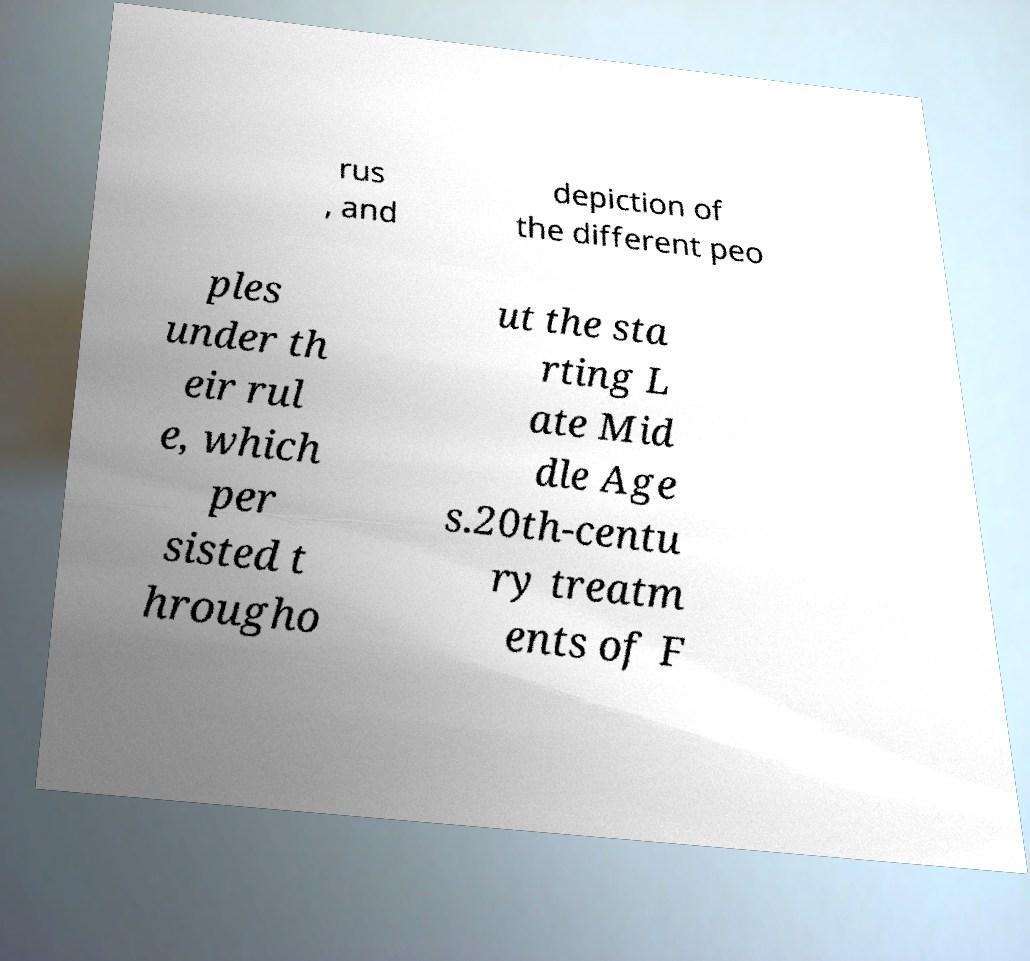Please identify and transcribe the text found in this image. rus , and depiction of the different peo ples under th eir rul e, which per sisted t hrougho ut the sta rting L ate Mid dle Age s.20th-centu ry treatm ents of F 